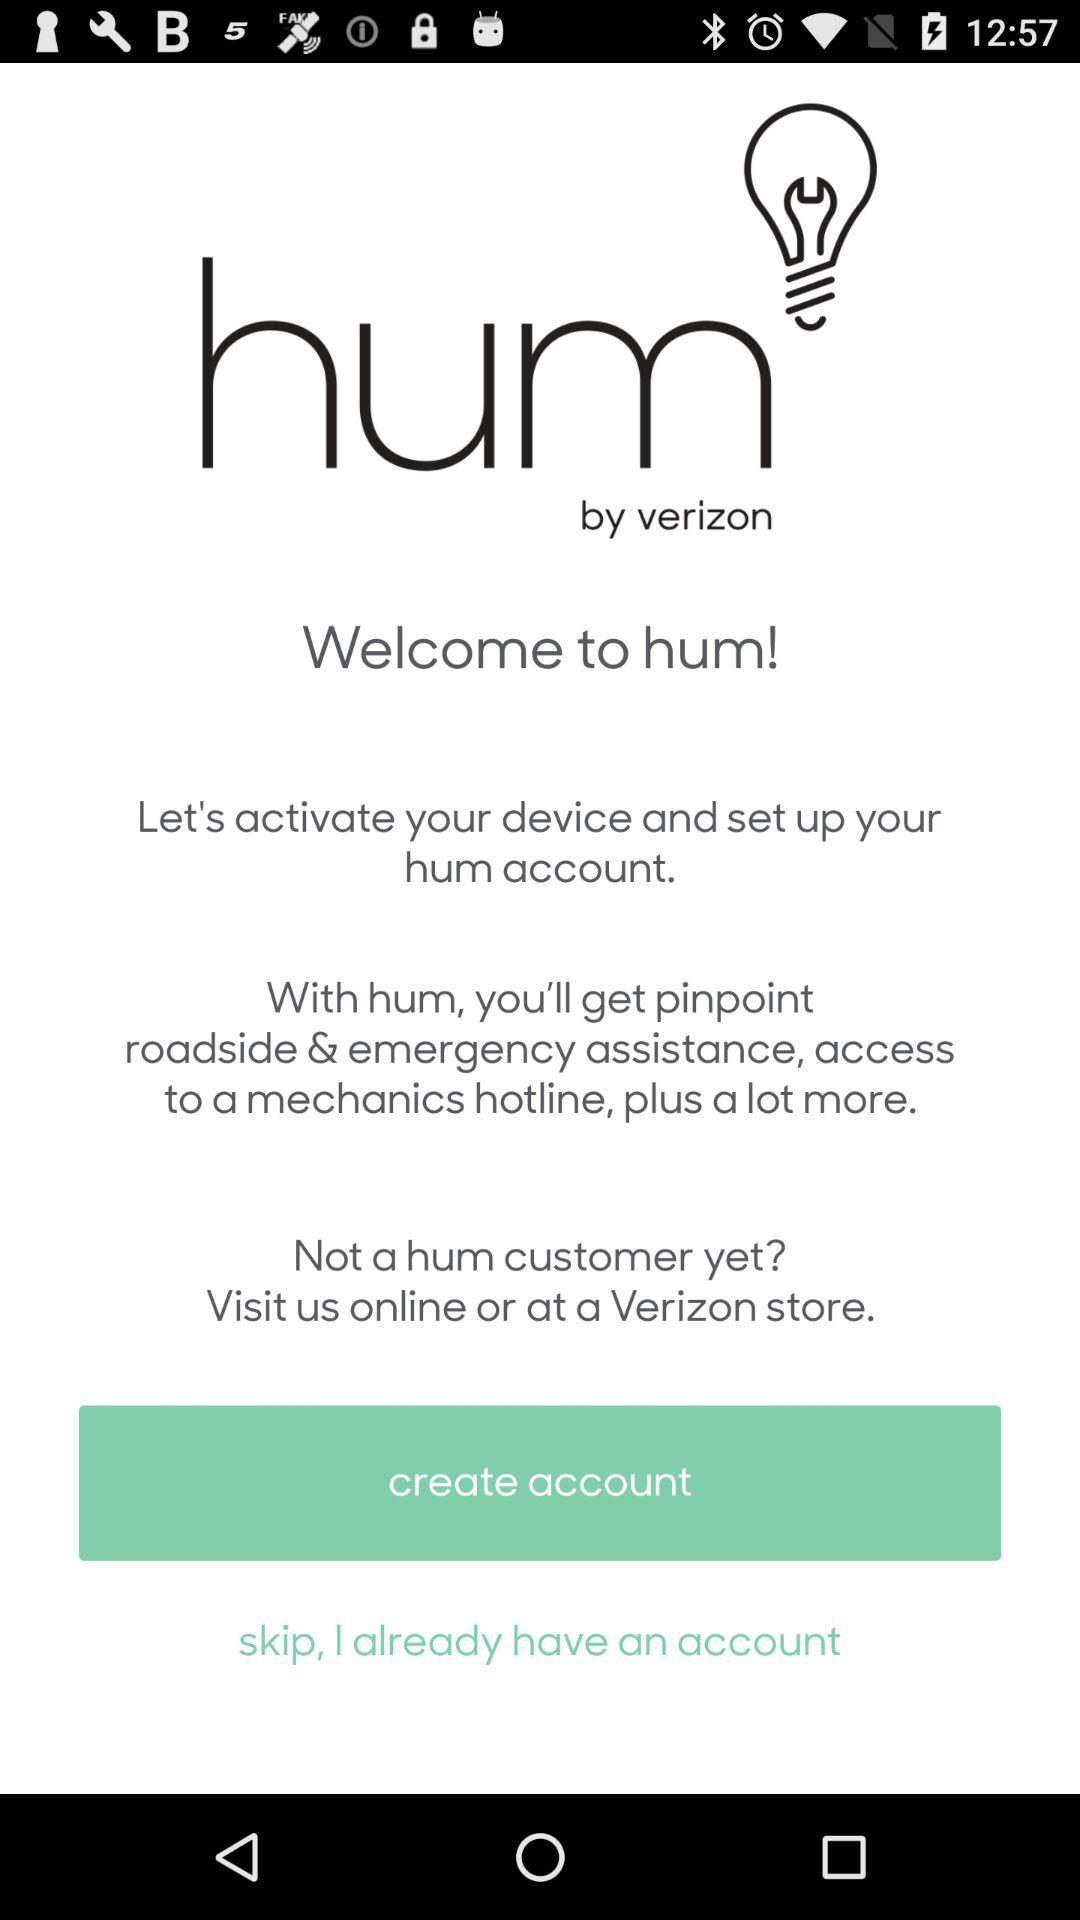What is the name of the application? The name of the application is "hum". 